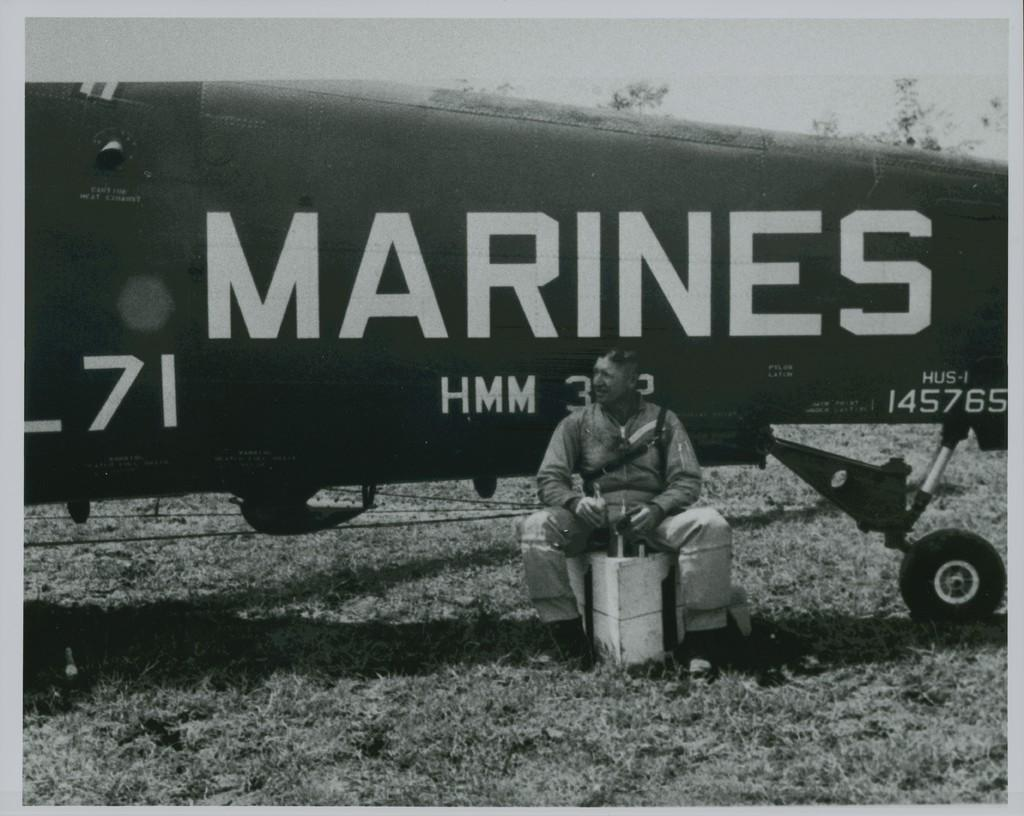Provide a one-sentence caption for the provided image. A man who is a marine is sitting on a box with a plane in the background. 